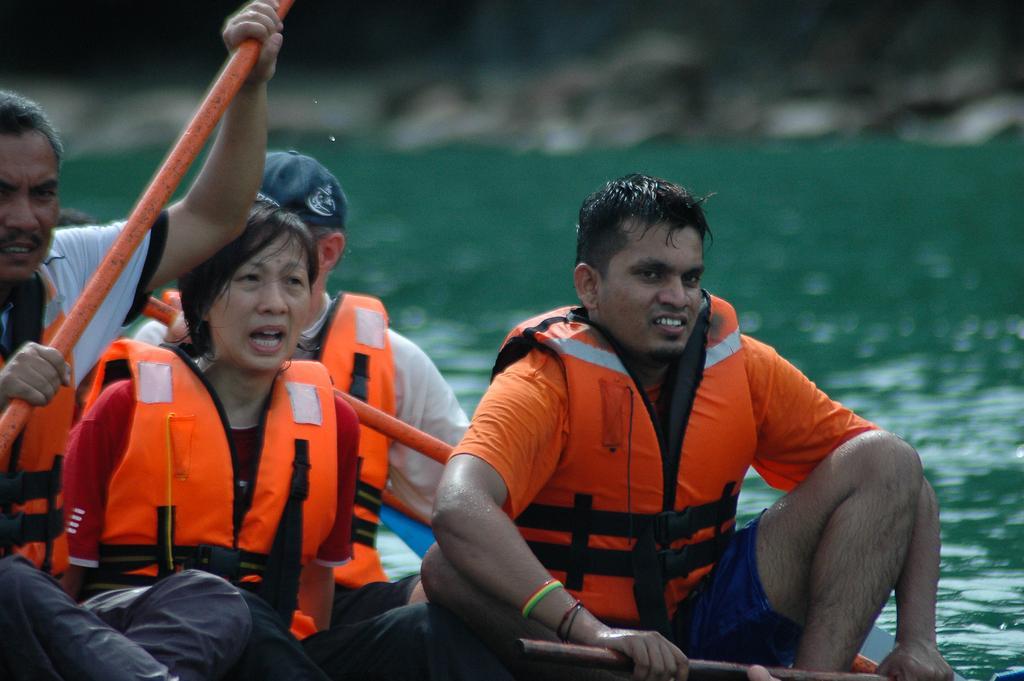Describe this image in one or two sentences. In this image there are a few people wearing hi-viz jackets are rafting on the water. 